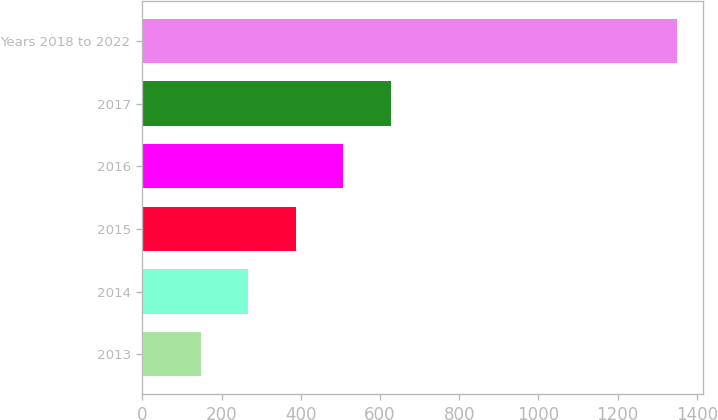Convert chart. <chart><loc_0><loc_0><loc_500><loc_500><bar_chart><fcel>2013<fcel>2014<fcel>2015<fcel>2016<fcel>2017<fcel>Years 2018 to 2022<nl><fcel>147<fcel>267.2<fcel>387.4<fcel>507.6<fcel>627.8<fcel>1349<nl></chart> 